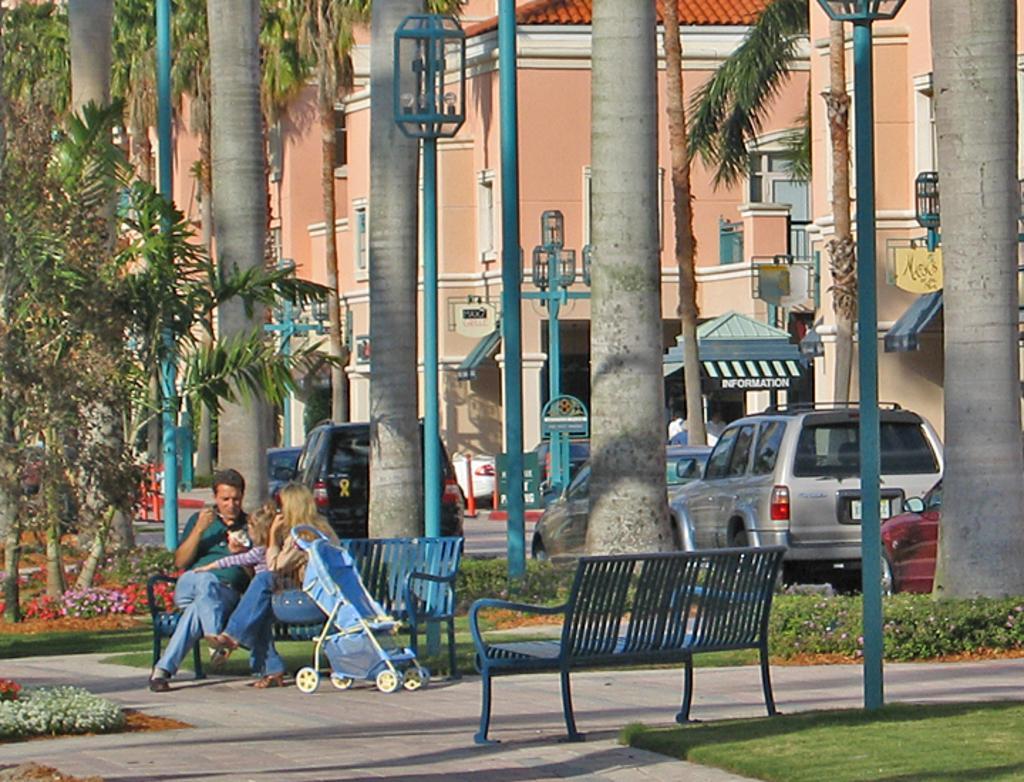In one or two sentences, can you explain what this image depicts? In this image I can see few buildings, trees, windows, light-poles, shed, traffic poles, benches, vehicles, trolley, colorful flowers and few people are sitting on the bench. 